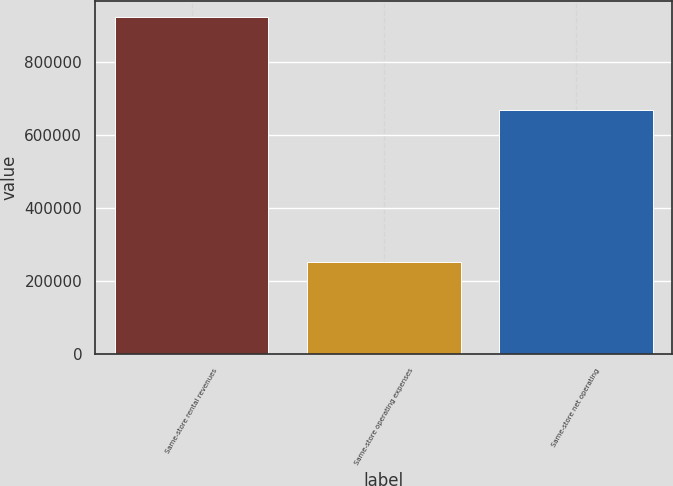<chart> <loc_0><loc_0><loc_500><loc_500><bar_chart><fcel>Same-store rental revenues<fcel>Same-store operating expenses<fcel>Same-store net operating<nl><fcel>921270<fcel>251853<fcel>669417<nl></chart> 